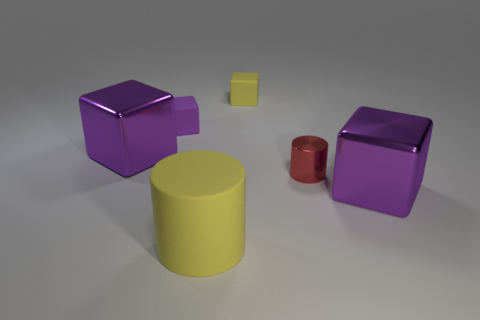There is a big shiny cube that is left of the yellow block; is its color the same as the rubber thing that is left of the big yellow matte thing?
Ensure brevity in your answer.  Yes. Are there any other things that have the same color as the large cylinder?
Offer a terse response. Yes. There is another object that is the same color as the large rubber thing; what shape is it?
Offer a very short reply. Cube. What color is the metal thing that is the same size as the purple rubber cube?
Your response must be concise. Red. What is the color of the big object that is in front of the purple thing that is in front of the small red metal cylinder?
Provide a short and direct response. Yellow. There is a rubber cube right of the purple rubber object; is it the same color as the big cylinder?
Offer a terse response. Yes. There is a big purple metallic thing that is to the right of the cylinder that is behind the big metallic thing in front of the small red metal cylinder; what is its shape?
Offer a very short reply. Cube. How many yellow matte things are on the right side of the thing that is on the left side of the tiny purple object?
Your response must be concise. 2. Is the large cylinder made of the same material as the tiny yellow block?
Make the answer very short. Yes. There is a large object that is in front of the large purple thing right of the yellow rubber cylinder; how many red shiny cylinders are left of it?
Offer a very short reply. 0. 